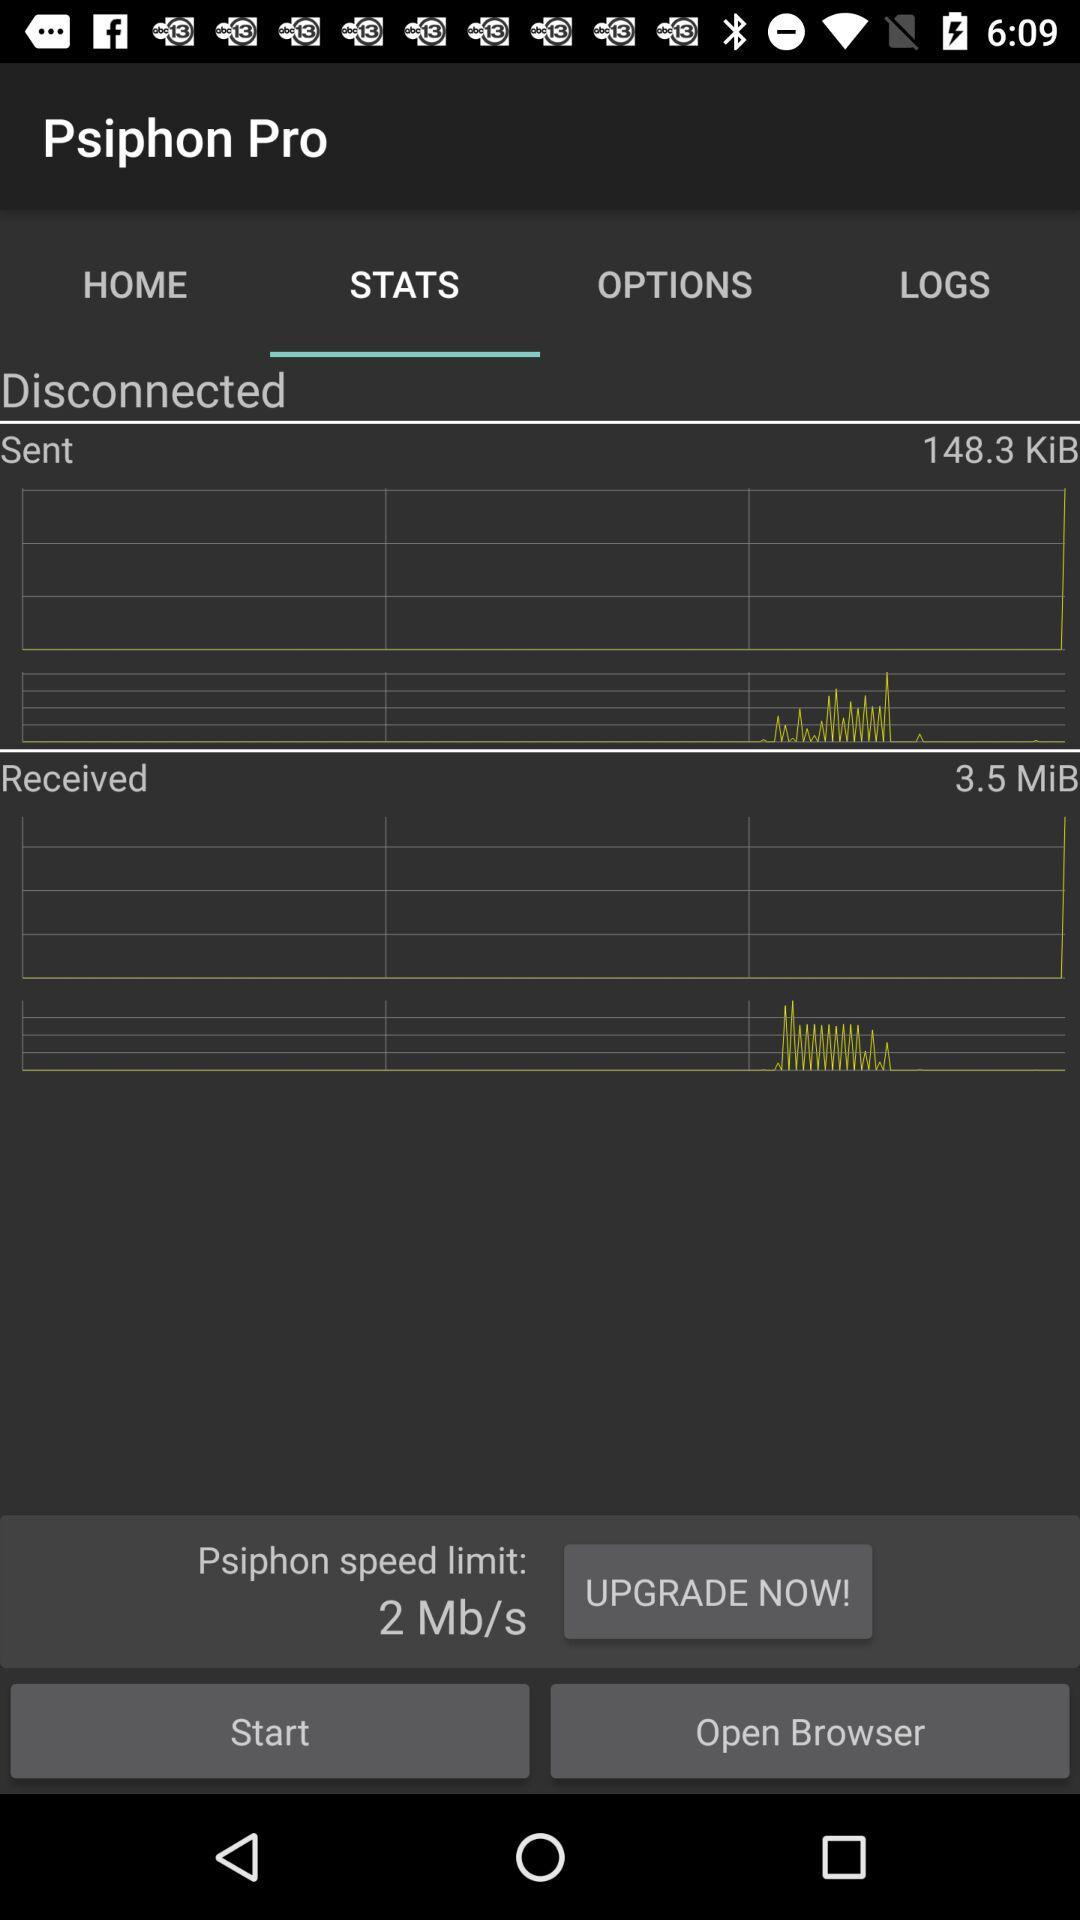How much data has been received in MiB? The data received in MiB is 3.5. 